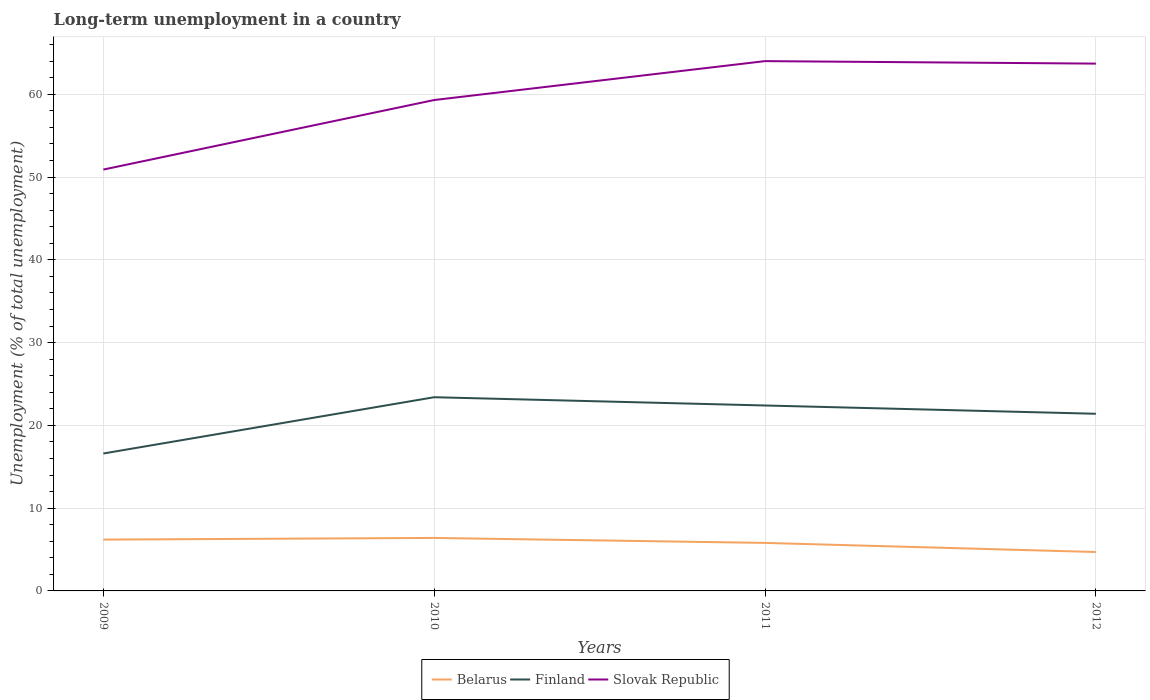How many different coloured lines are there?
Your response must be concise. 3. Does the line corresponding to Finland intersect with the line corresponding to Belarus?
Provide a short and direct response. No. Is the number of lines equal to the number of legend labels?
Your response must be concise. Yes. Across all years, what is the maximum percentage of long-term unemployed population in Slovak Republic?
Your answer should be very brief. 50.9. What is the total percentage of long-term unemployed population in Belarus in the graph?
Offer a very short reply. 1.5. What is the difference between the highest and the second highest percentage of long-term unemployed population in Finland?
Provide a short and direct response. 6.8. What is the difference between the highest and the lowest percentage of long-term unemployed population in Finland?
Offer a terse response. 3. Is the percentage of long-term unemployed population in Finland strictly greater than the percentage of long-term unemployed population in Belarus over the years?
Your response must be concise. No. How many years are there in the graph?
Keep it short and to the point. 4. Does the graph contain grids?
Your answer should be very brief. Yes. Where does the legend appear in the graph?
Keep it short and to the point. Bottom center. What is the title of the graph?
Keep it short and to the point. Long-term unemployment in a country. What is the label or title of the Y-axis?
Give a very brief answer. Unemployment (% of total unemployment). What is the Unemployment (% of total unemployment) of Belarus in 2009?
Ensure brevity in your answer.  6.2. What is the Unemployment (% of total unemployment) in Finland in 2009?
Offer a very short reply. 16.6. What is the Unemployment (% of total unemployment) of Slovak Republic in 2009?
Your answer should be very brief. 50.9. What is the Unemployment (% of total unemployment) of Belarus in 2010?
Your answer should be compact. 6.4. What is the Unemployment (% of total unemployment) of Finland in 2010?
Your answer should be very brief. 23.4. What is the Unemployment (% of total unemployment) of Slovak Republic in 2010?
Ensure brevity in your answer.  59.3. What is the Unemployment (% of total unemployment) of Belarus in 2011?
Offer a terse response. 5.8. What is the Unemployment (% of total unemployment) of Finland in 2011?
Your response must be concise. 22.4. What is the Unemployment (% of total unemployment) of Slovak Republic in 2011?
Keep it short and to the point. 64. What is the Unemployment (% of total unemployment) of Belarus in 2012?
Keep it short and to the point. 4.7. What is the Unemployment (% of total unemployment) of Finland in 2012?
Offer a terse response. 21.4. What is the Unemployment (% of total unemployment) in Slovak Republic in 2012?
Your answer should be compact. 63.7. Across all years, what is the maximum Unemployment (% of total unemployment) of Belarus?
Offer a very short reply. 6.4. Across all years, what is the maximum Unemployment (% of total unemployment) in Finland?
Make the answer very short. 23.4. Across all years, what is the minimum Unemployment (% of total unemployment) in Belarus?
Give a very brief answer. 4.7. Across all years, what is the minimum Unemployment (% of total unemployment) of Finland?
Your answer should be very brief. 16.6. Across all years, what is the minimum Unemployment (% of total unemployment) in Slovak Republic?
Make the answer very short. 50.9. What is the total Unemployment (% of total unemployment) in Belarus in the graph?
Provide a succinct answer. 23.1. What is the total Unemployment (% of total unemployment) in Finland in the graph?
Provide a short and direct response. 83.8. What is the total Unemployment (% of total unemployment) of Slovak Republic in the graph?
Ensure brevity in your answer.  237.9. What is the difference between the Unemployment (% of total unemployment) of Finland in 2009 and that in 2010?
Offer a very short reply. -6.8. What is the difference between the Unemployment (% of total unemployment) of Belarus in 2009 and that in 2011?
Provide a succinct answer. 0.4. What is the difference between the Unemployment (% of total unemployment) in Finland in 2009 and that in 2011?
Give a very brief answer. -5.8. What is the difference between the Unemployment (% of total unemployment) in Slovak Republic in 2009 and that in 2011?
Keep it short and to the point. -13.1. What is the difference between the Unemployment (% of total unemployment) of Belarus in 2009 and that in 2012?
Provide a succinct answer. 1.5. What is the difference between the Unemployment (% of total unemployment) of Finland in 2009 and that in 2012?
Offer a very short reply. -4.8. What is the difference between the Unemployment (% of total unemployment) in Slovak Republic in 2009 and that in 2012?
Offer a terse response. -12.8. What is the difference between the Unemployment (% of total unemployment) in Slovak Republic in 2010 and that in 2011?
Keep it short and to the point. -4.7. What is the difference between the Unemployment (% of total unemployment) in Belarus in 2010 and that in 2012?
Your answer should be compact. 1.7. What is the difference between the Unemployment (% of total unemployment) of Finland in 2010 and that in 2012?
Offer a very short reply. 2. What is the difference between the Unemployment (% of total unemployment) in Slovak Republic in 2010 and that in 2012?
Make the answer very short. -4.4. What is the difference between the Unemployment (% of total unemployment) in Finland in 2011 and that in 2012?
Keep it short and to the point. 1. What is the difference between the Unemployment (% of total unemployment) in Belarus in 2009 and the Unemployment (% of total unemployment) in Finland in 2010?
Give a very brief answer. -17.2. What is the difference between the Unemployment (% of total unemployment) of Belarus in 2009 and the Unemployment (% of total unemployment) of Slovak Republic in 2010?
Provide a succinct answer. -53.1. What is the difference between the Unemployment (% of total unemployment) in Finland in 2009 and the Unemployment (% of total unemployment) in Slovak Republic in 2010?
Your answer should be compact. -42.7. What is the difference between the Unemployment (% of total unemployment) in Belarus in 2009 and the Unemployment (% of total unemployment) in Finland in 2011?
Keep it short and to the point. -16.2. What is the difference between the Unemployment (% of total unemployment) of Belarus in 2009 and the Unemployment (% of total unemployment) of Slovak Republic in 2011?
Give a very brief answer. -57.8. What is the difference between the Unemployment (% of total unemployment) of Finland in 2009 and the Unemployment (% of total unemployment) of Slovak Republic in 2011?
Offer a very short reply. -47.4. What is the difference between the Unemployment (% of total unemployment) in Belarus in 2009 and the Unemployment (% of total unemployment) in Finland in 2012?
Offer a terse response. -15.2. What is the difference between the Unemployment (% of total unemployment) in Belarus in 2009 and the Unemployment (% of total unemployment) in Slovak Republic in 2012?
Ensure brevity in your answer.  -57.5. What is the difference between the Unemployment (% of total unemployment) in Finland in 2009 and the Unemployment (% of total unemployment) in Slovak Republic in 2012?
Your response must be concise. -47.1. What is the difference between the Unemployment (% of total unemployment) of Belarus in 2010 and the Unemployment (% of total unemployment) of Slovak Republic in 2011?
Make the answer very short. -57.6. What is the difference between the Unemployment (% of total unemployment) of Finland in 2010 and the Unemployment (% of total unemployment) of Slovak Republic in 2011?
Your response must be concise. -40.6. What is the difference between the Unemployment (% of total unemployment) in Belarus in 2010 and the Unemployment (% of total unemployment) in Slovak Republic in 2012?
Your answer should be very brief. -57.3. What is the difference between the Unemployment (% of total unemployment) of Finland in 2010 and the Unemployment (% of total unemployment) of Slovak Republic in 2012?
Provide a short and direct response. -40.3. What is the difference between the Unemployment (% of total unemployment) of Belarus in 2011 and the Unemployment (% of total unemployment) of Finland in 2012?
Make the answer very short. -15.6. What is the difference between the Unemployment (% of total unemployment) in Belarus in 2011 and the Unemployment (% of total unemployment) in Slovak Republic in 2012?
Ensure brevity in your answer.  -57.9. What is the difference between the Unemployment (% of total unemployment) of Finland in 2011 and the Unemployment (% of total unemployment) of Slovak Republic in 2012?
Offer a very short reply. -41.3. What is the average Unemployment (% of total unemployment) in Belarus per year?
Offer a terse response. 5.78. What is the average Unemployment (% of total unemployment) in Finland per year?
Provide a succinct answer. 20.95. What is the average Unemployment (% of total unemployment) of Slovak Republic per year?
Offer a terse response. 59.48. In the year 2009, what is the difference between the Unemployment (% of total unemployment) in Belarus and Unemployment (% of total unemployment) in Slovak Republic?
Your answer should be compact. -44.7. In the year 2009, what is the difference between the Unemployment (% of total unemployment) of Finland and Unemployment (% of total unemployment) of Slovak Republic?
Keep it short and to the point. -34.3. In the year 2010, what is the difference between the Unemployment (% of total unemployment) in Belarus and Unemployment (% of total unemployment) in Slovak Republic?
Offer a very short reply. -52.9. In the year 2010, what is the difference between the Unemployment (% of total unemployment) of Finland and Unemployment (% of total unemployment) of Slovak Republic?
Your answer should be compact. -35.9. In the year 2011, what is the difference between the Unemployment (% of total unemployment) of Belarus and Unemployment (% of total unemployment) of Finland?
Make the answer very short. -16.6. In the year 2011, what is the difference between the Unemployment (% of total unemployment) of Belarus and Unemployment (% of total unemployment) of Slovak Republic?
Your answer should be very brief. -58.2. In the year 2011, what is the difference between the Unemployment (% of total unemployment) in Finland and Unemployment (% of total unemployment) in Slovak Republic?
Provide a short and direct response. -41.6. In the year 2012, what is the difference between the Unemployment (% of total unemployment) in Belarus and Unemployment (% of total unemployment) in Finland?
Your answer should be very brief. -16.7. In the year 2012, what is the difference between the Unemployment (% of total unemployment) of Belarus and Unemployment (% of total unemployment) of Slovak Republic?
Your answer should be compact. -59. In the year 2012, what is the difference between the Unemployment (% of total unemployment) in Finland and Unemployment (% of total unemployment) in Slovak Republic?
Keep it short and to the point. -42.3. What is the ratio of the Unemployment (% of total unemployment) in Belarus in 2009 to that in 2010?
Provide a succinct answer. 0.97. What is the ratio of the Unemployment (% of total unemployment) of Finland in 2009 to that in 2010?
Make the answer very short. 0.71. What is the ratio of the Unemployment (% of total unemployment) of Slovak Republic in 2009 to that in 2010?
Make the answer very short. 0.86. What is the ratio of the Unemployment (% of total unemployment) in Belarus in 2009 to that in 2011?
Give a very brief answer. 1.07. What is the ratio of the Unemployment (% of total unemployment) in Finland in 2009 to that in 2011?
Offer a very short reply. 0.74. What is the ratio of the Unemployment (% of total unemployment) in Slovak Republic in 2009 to that in 2011?
Ensure brevity in your answer.  0.8. What is the ratio of the Unemployment (% of total unemployment) of Belarus in 2009 to that in 2012?
Make the answer very short. 1.32. What is the ratio of the Unemployment (% of total unemployment) in Finland in 2009 to that in 2012?
Ensure brevity in your answer.  0.78. What is the ratio of the Unemployment (% of total unemployment) in Slovak Republic in 2009 to that in 2012?
Provide a succinct answer. 0.8. What is the ratio of the Unemployment (% of total unemployment) in Belarus in 2010 to that in 2011?
Your answer should be compact. 1.1. What is the ratio of the Unemployment (% of total unemployment) of Finland in 2010 to that in 2011?
Make the answer very short. 1.04. What is the ratio of the Unemployment (% of total unemployment) in Slovak Republic in 2010 to that in 2011?
Provide a short and direct response. 0.93. What is the ratio of the Unemployment (% of total unemployment) in Belarus in 2010 to that in 2012?
Your response must be concise. 1.36. What is the ratio of the Unemployment (% of total unemployment) of Finland in 2010 to that in 2012?
Keep it short and to the point. 1.09. What is the ratio of the Unemployment (% of total unemployment) in Slovak Republic in 2010 to that in 2012?
Keep it short and to the point. 0.93. What is the ratio of the Unemployment (% of total unemployment) of Belarus in 2011 to that in 2012?
Your answer should be very brief. 1.23. What is the ratio of the Unemployment (% of total unemployment) in Finland in 2011 to that in 2012?
Offer a terse response. 1.05. What is the difference between the highest and the second highest Unemployment (% of total unemployment) in Slovak Republic?
Make the answer very short. 0.3. What is the difference between the highest and the lowest Unemployment (% of total unemployment) in Belarus?
Your answer should be very brief. 1.7. What is the difference between the highest and the lowest Unemployment (% of total unemployment) of Finland?
Provide a succinct answer. 6.8. What is the difference between the highest and the lowest Unemployment (% of total unemployment) of Slovak Republic?
Offer a terse response. 13.1. 